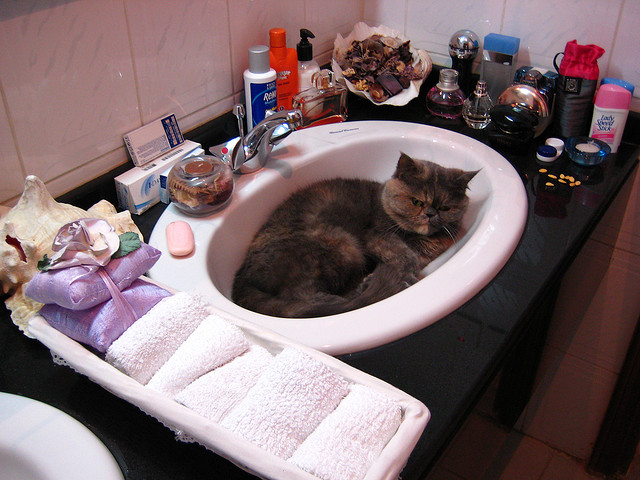Do you see deodorant on the sink top? Yes, there is a stick of deodorant positioned near the front of the sink, to the left of the faucet. 